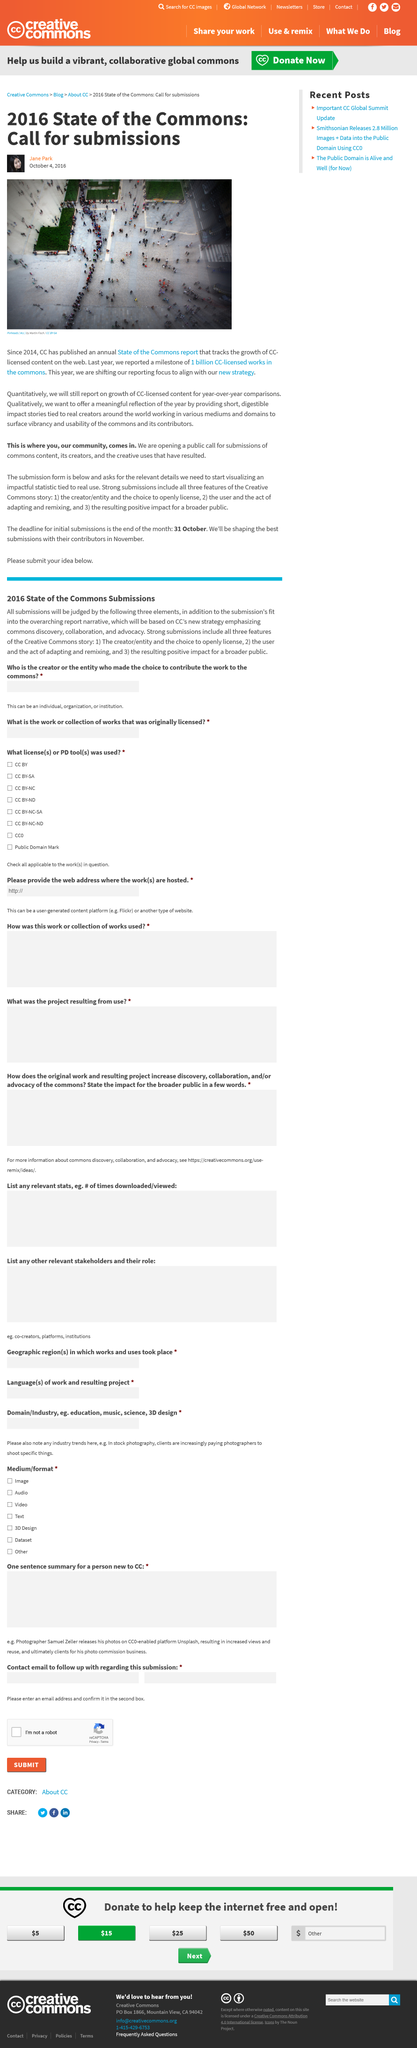Give some essential details in this illustration. The State of the Commons report tracks the growth of content licensed under the Creative Commons (CC) license on the internet, providing insight into the use and impact of this type of open license. The photograph in question is titled "Pinheads" and is credited to the artist Martin Fisch. 